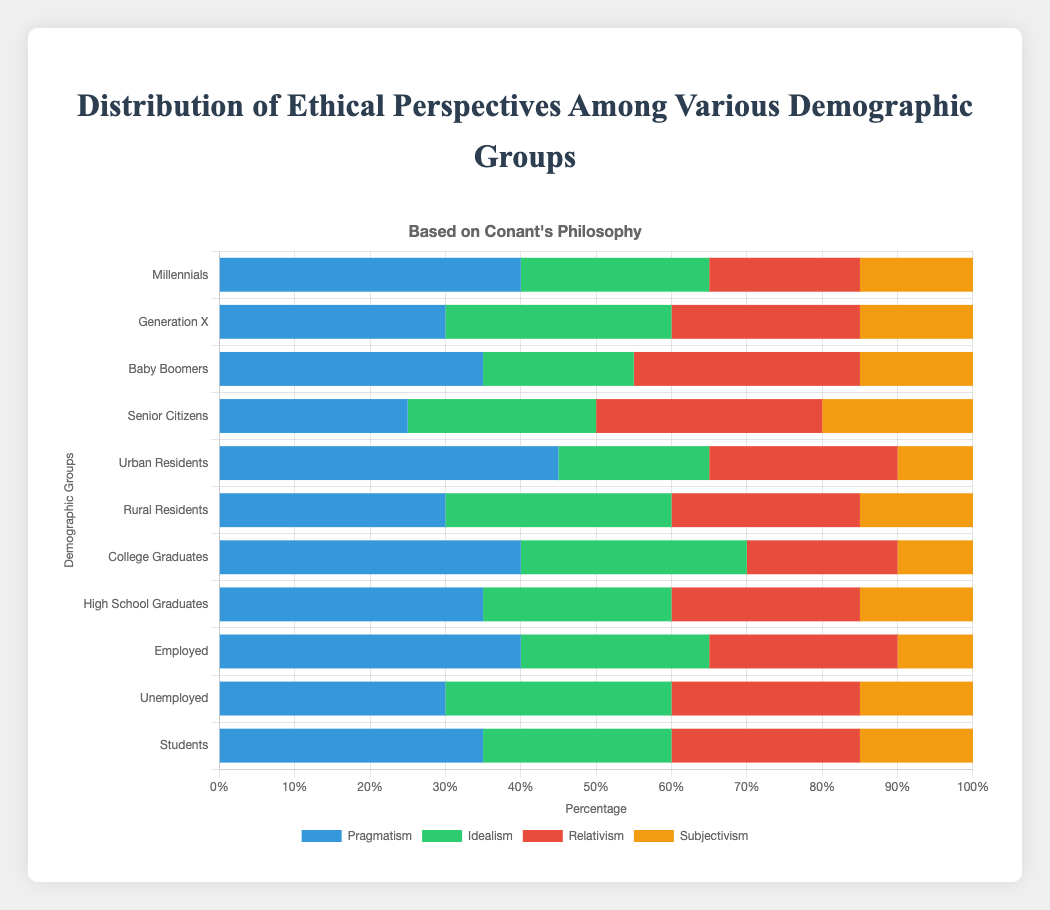**Question**: Which demographic group has the highest percentage of Pragmatism? **Explanation**: To find the group with the highest percentage of Pragmatism, we look at the Pragmatism values in the dataset and compare them. Urban Residents have the highest percentage at 45%.
Answer: **Concise Answer**: Urban Residents **Question**: What is the combined percentage of Idealism and Subjectivism for Generation X? **Explanation**: For Generation X, Idealism is 30% and Subjectivism is 15%. Adding these percentages together: 30% + 15% = 45%.
Answer: **Concise Answer**: 45% **Question**: Which demographic group has the lowest percentage for Subjectivism? **Explanation**: By examining the data for Subjectivism across all groups, Urban Residents have the lowest percentage at 10%.
Answer: **Concise Answer**: Urban Residents **Question**: How does the Pragmatism percentage of Millennials compare to that of Baby Boomers? **Explanation**: Millennials have a Pragmatism percentage of 40%, and Baby Boomers have 35%. Therefore, Millennials' Pragmatism percentage is higher than that of Baby Boomers by 5%.
Answer: **Concise Answer**: Higher by 5% **Question**: What is the difference between the percentage of Pragmatism and Relativism for Senior Citizens? **Explanation**: For Senior Citizens, Pragmatism is 25% and Relativism is 30%. Subtracting Pragmatism from Relativism: 30% - 25% = 5%.
Answer: **Concise Answer**: 5% **Question**: What are the visual attributes (color and relative width) for the highest Idealism percentage in the chart? **Explanation**: The color representing Idealism is green, and the highest Idealism percentage is 30% found among Generation X, Rural Residents, College Graduates, and the Unemployed. The green bar representing these groups for Idealism will be of medium width, as 30% is not the highest overall percentage in the chart.
Answer: **Concise Answer**: Green, medium width **Question**: What is the average value of Pragmatism across all demographic groups? **Explanation**: The values of Pragmatism across all demographic groups are: 40, 30, 35, 25, 45, 30, 40, 35, 40, 30, 35. Adding these values gives 385. There are 11 groups, so the average is 385 / 11 ≈ 35%.
Answer: **Concise Answer**: 35% **Question**: Which demographic group has more people aligning with Relativism compared to Idealism? **Explanation**: We look at the groups where the percentage for Relativism is higher than for Idealism. These groups are Baby Boomers and Senior Citizens.
Answer: **Concise Answer**: Baby Boomers and Senior Citizens **Question**: What is the total percentage of ethical perspectives represented in the Urban Residents group? **Explanation**: Adding up all the percentages: Pragmatism (45%) + Idealism (20%) + Relativism (25%) + Subjectivism (10%) = 100%.
Answer: **Concise Answer**: 100% **Question**: Among employed and unemployed groups, which one has a higher percentage of Idealism? **Explanation**: The percentage of Idealism for the Employed group is 25%, and for the Unemployed group, it is 30%. Therefore, the Unemployed group has a higher percentage.
Answer: **Concise Answer**: Unemployed 